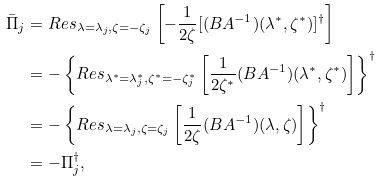<formula> <loc_0><loc_0><loc_500><loc_500>\bar { \Pi } _ { j } & = R e s _ { \lambda = \lambda _ { j } , \zeta = - \zeta _ { j } } \left [ - \frac { 1 } { 2 \zeta } [ ( B A ^ { - 1 } ) ( \lambda ^ { * } , \zeta ^ { * } ) ] ^ { \dagger } \right ] \\ & = - \left \{ R e s _ { \lambda ^ { * } = \lambda _ { j } ^ { * } , \zeta ^ { * } = - \zeta _ { j } ^ { * } } \left [ \frac { 1 } { 2 \zeta ^ { * } } ( B A ^ { - 1 } ) ( \lambda ^ { * } , \zeta ^ { * } ) \right ] \right \} ^ { \dagger } \\ & = - \left \{ R e s _ { \lambda = \lambda _ { j } , \zeta = \zeta _ { j } } \left [ \frac { 1 } { 2 \zeta } ( B A ^ { - 1 } ) ( \lambda , \zeta ) \right ] \right \} ^ { \dagger } \\ & = - \Pi _ { j } ^ { \dagger } ,</formula> 